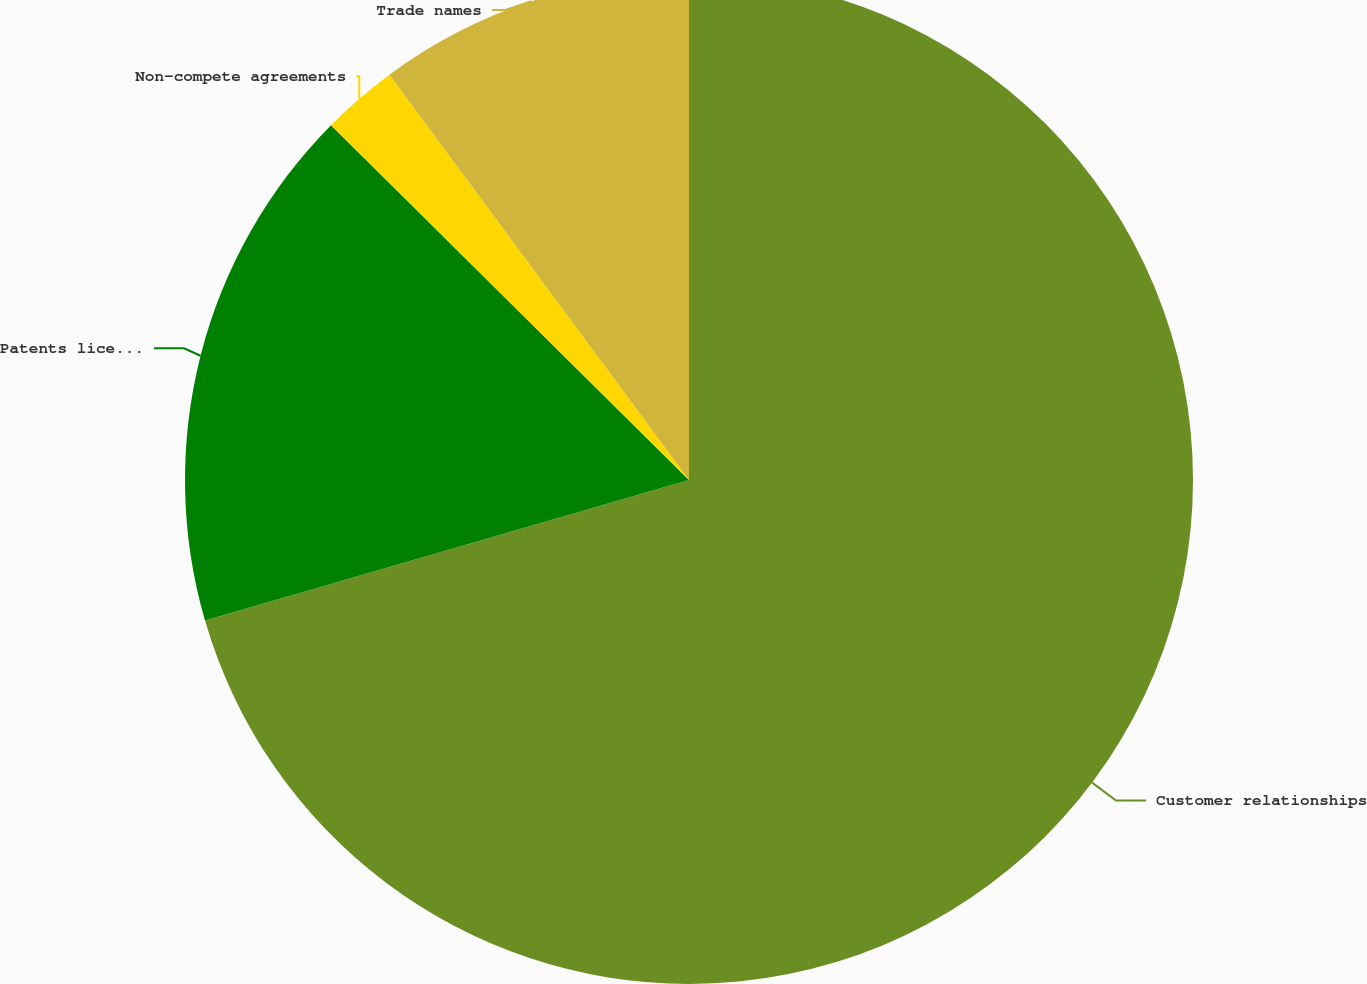<chart> <loc_0><loc_0><loc_500><loc_500><pie_chart><fcel>Customer relationships<fcel>Patents licenses and<fcel>Non-compete agreements<fcel>Trade names<nl><fcel>70.5%<fcel>16.93%<fcel>2.44%<fcel>10.13%<nl></chart> 